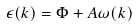<formula> <loc_0><loc_0><loc_500><loc_500>\epsilon ( k ) = \Phi + A \omega ( k )</formula> 